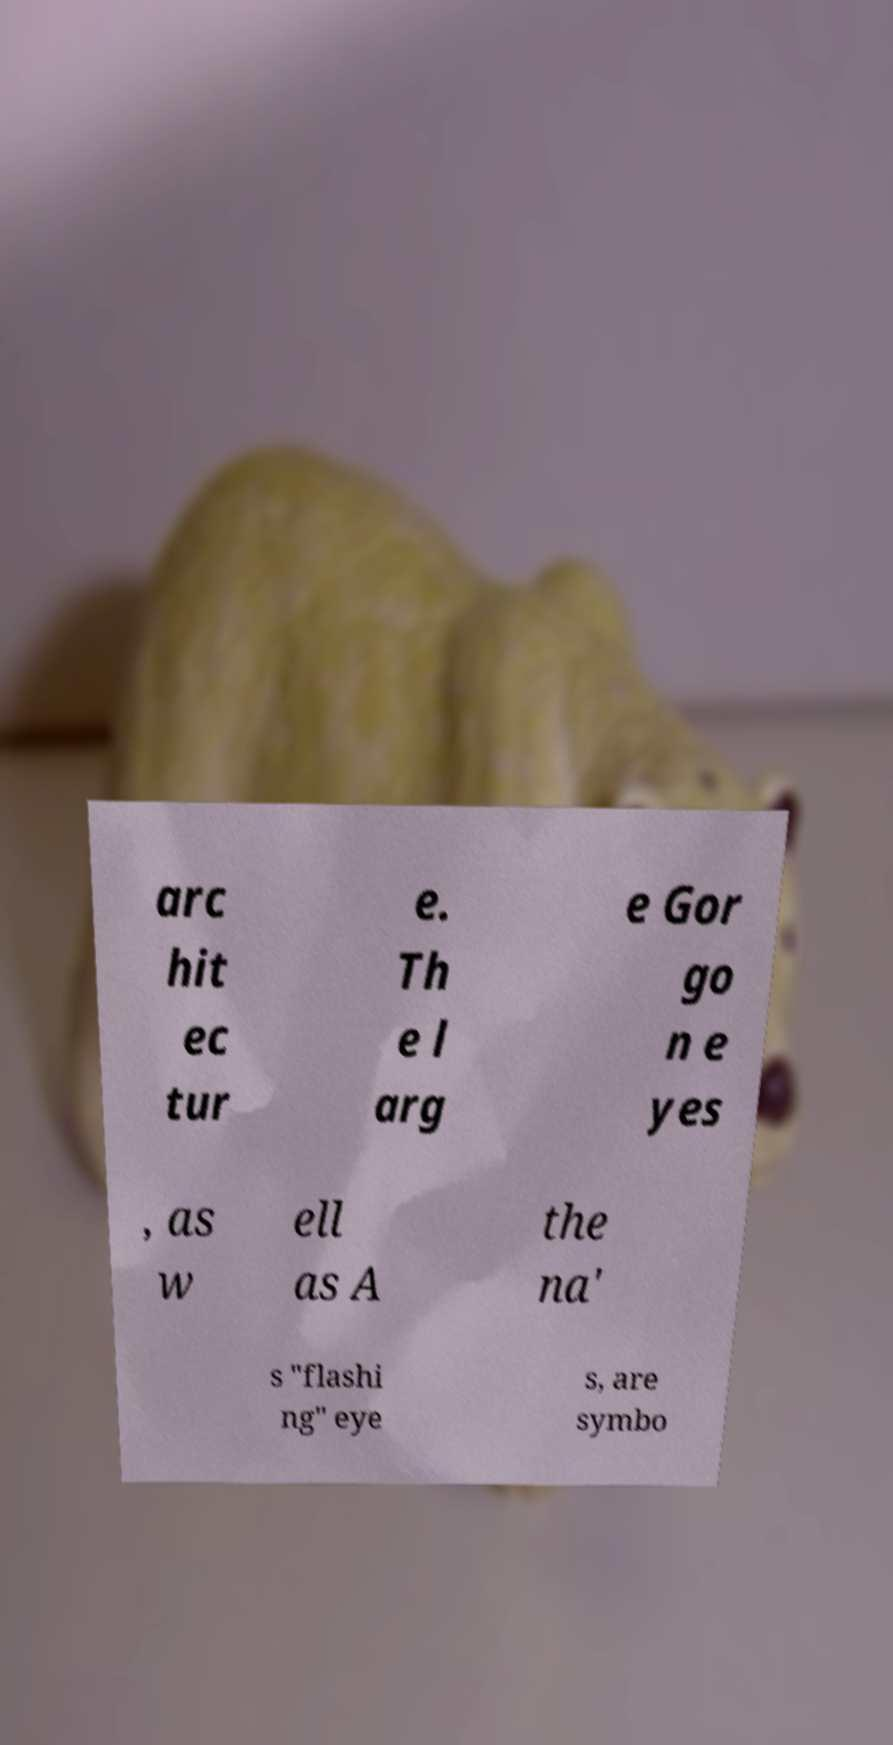Please read and relay the text visible in this image. What does it say? arc hit ec tur e. Th e l arg e Gor go n e yes , as w ell as A the na' s "flashi ng" eye s, are symbo 